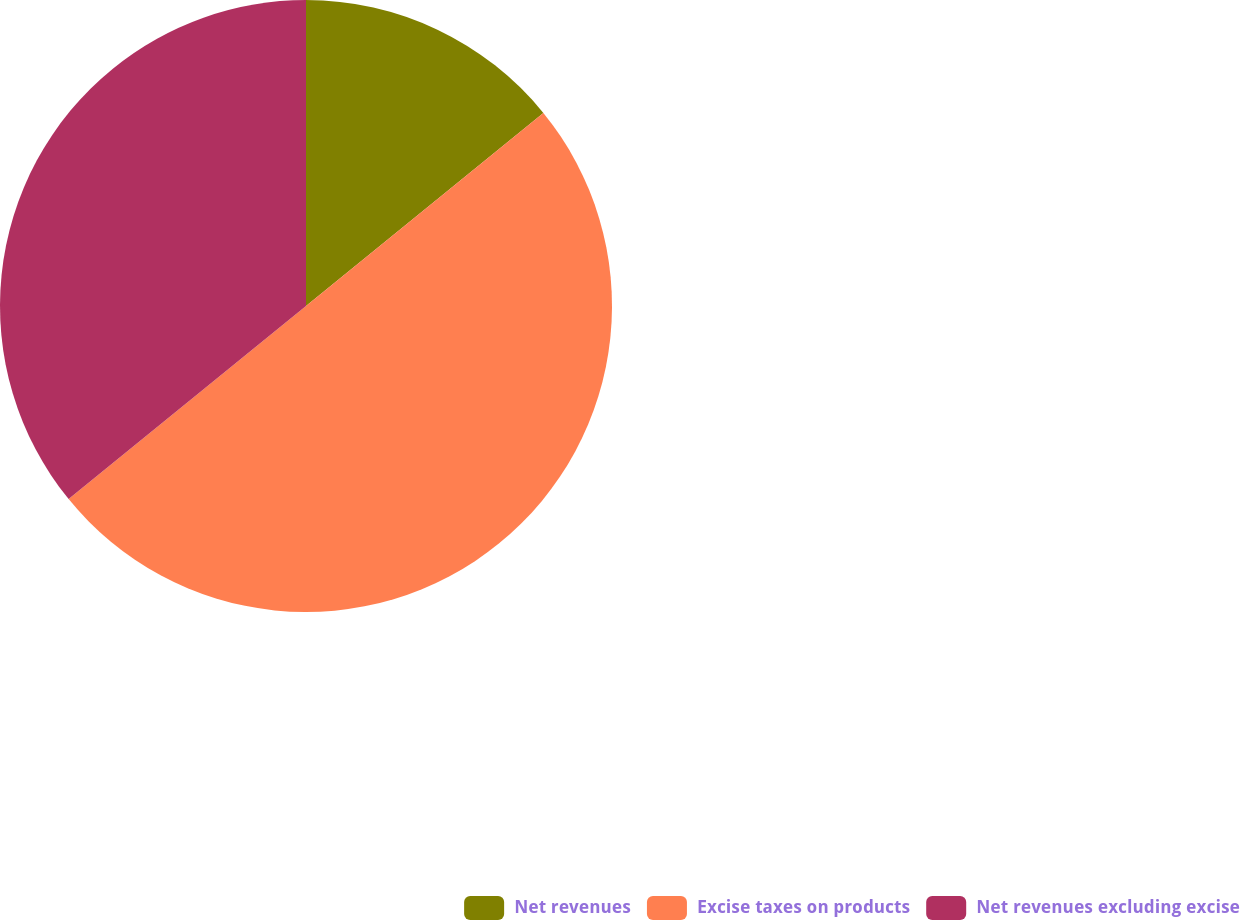Convert chart to OTSL. <chart><loc_0><loc_0><loc_500><loc_500><pie_chart><fcel>Net revenues<fcel>Excise taxes on products<fcel>Net revenues excluding excise<nl><fcel>14.13%<fcel>50.0%<fcel>35.87%<nl></chart> 